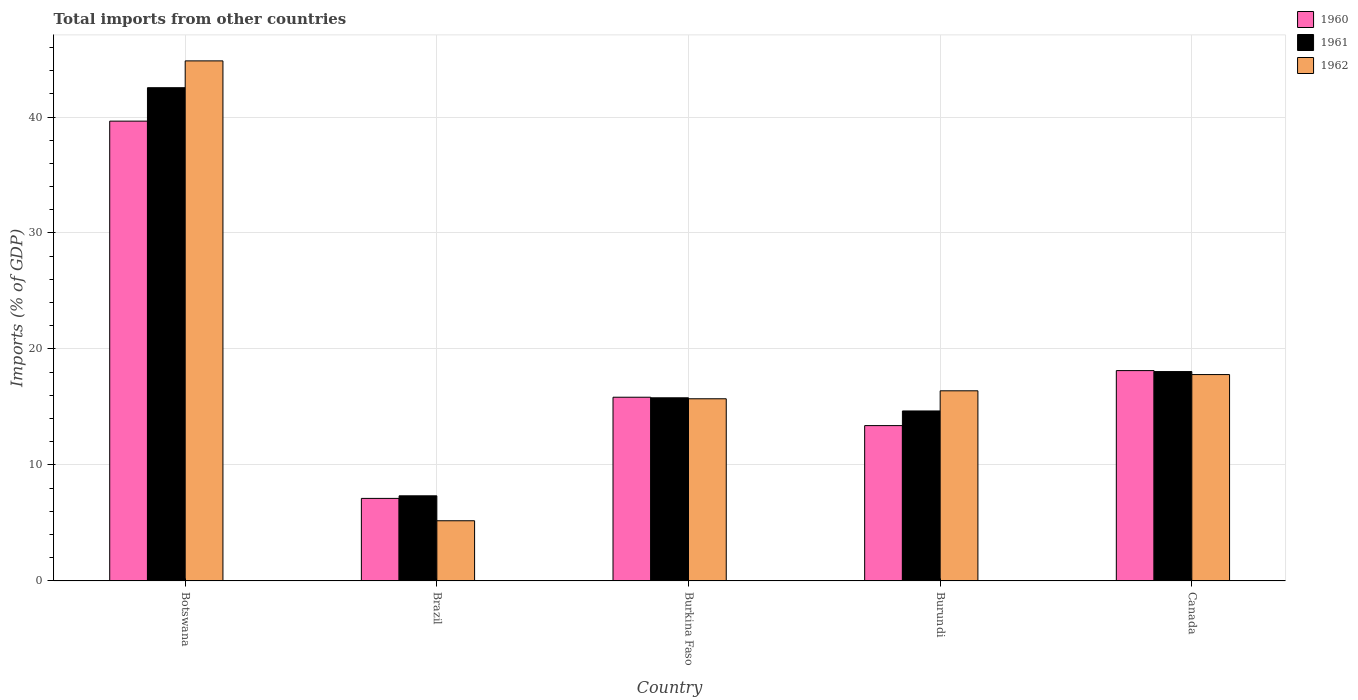Are the number of bars on each tick of the X-axis equal?
Your answer should be compact. Yes. How many bars are there on the 4th tick from the left?
Ensure brevity in your answer.  3. How many bars are there on the 2nd tick from the right?
Your answer should be compact. 3. What is the label of the 1st group of bars from the left?
Make the answer very short. Botswana. What is the total imports in 1960 in Burkina Faso?
Keep it short and to the point. 15.84. Across all countries, what is the maximum total imports in 1962?
Offer a very short reply. 44.84. Across all countries, what is the minimum total imports in 1961?
Your response must be concise. 7.34. In which country was the total imports in 1960 maximum?
Make the answer very short. Botswana. What is the total total imports in 1960 in the graph?
Keep it short and to the point. 94.13. What is the difference between the total imports in 1960 in Brazil and that in Burundi?
Make the answer very short. -6.28. What is the difference between the total imports in 1961 in Brazil and the total imports in 1960 in Botswana?
Provide a short and direct response. -32.3. What is the average total imports in 1962 per country?
Ensure brevity in your answer.  19.98. What is the difference between the total imports of/in 1961 and total imports of/in 1962 in Burkina Faso?
Provide a succinct answer. 0.08. In how many countries, is the total imports in 1960 greater than 30 %?
Your answer should be very brief. 1. What is the ratio of the total imports in 1960 in Burkina Faso to that in Canada?
Give a very brief answer. 0.87. What is the difference between the highest and the second highest total imports in 1960?
Give a very brief answer. 2.3. What is the difference between the highest and the lowest total imports in 1960?
Give a very brief answer. 32.53. What does the 3rd bar from the right in Brazil represents?
Your response must be concise. 1960. Are the values on the major ticks of Y-axis written in scientific E-notation?
Your response must be concise. No. Does the graph contain any zero values?
Your answer should be very brief. No. Does the graph contain grids?
Keep it short and to the point. Yes. Where does the legend appear in the graph?
Provide a short and direct response. Top right. How many legend labels are there?
Offer a very short reply. 3. How are the legend labels stacked?
Give a very brief answer. Vertical. What is the title of the graph?
Your answer should be compact. Total imports from other countries. Does "1983" appear as one of the legend labels in the graph?
Make the answer very short. No. What is the label or title of the X-axis?
Your response must be concise. Country. What is the label or title of the Y-axis?
Your response must be concise. Imports (% of GDP). What is the Imports (% of GDP) in 1960 in Botswana?
Provide a short and direct response. 39.64. What is the Imports (% of GDP) of 1961 in Botswana?
Provide a succinct answer. 42.53. What is the Imports (% of GDP) in 1962 in Botswana?
Your answer should be compact. 44.84. What is the Imports (% of GDP) in 1960 in Brazil?
Your answer should be very brief. 7.12. What is the Imports (% of GDP) in 1961 in Brazil?
Keep it short and to the point. 7.34. What is the Imports (% of GDP) in 1962 in Brazil?
Offer a terse response. 5.19. What is the Imports (% of GDP) of 1960 in Burkina Faso?
Make the answer very short. 15.84. What is the Imports (% of GDP) of 1961 in Burkina Faso?
Make the answer very short. 15.79. What is the Imports (% of GDP) in 1962 in Burkina Faso?
Keep it short and to the point. 15.71. What is the Imports (% of GDP) of 1960 in Burundi?
Provide a short and direct response. 13.39. What is the Imports (% of GDP) in 1961 in Burundi?
Give a very brief answer. 14.66. What is the Imports (% of GDP) of 1962 in Burundi?
Make the answer very short. 16.39. What is the Imports (% of GDP) of 1960 in Canada?
Offer a very short reply. 18.14. What is the Imports (% of GDP) in 1961 in Canada?
Offer a terse response. 18.05. What is the Imports (% of GDP) of 1962 in Canada?
Your answer should be compact. 17.79. Across all countries, what is the maximum Imports (% of GDP) in 1960?
Make the answer very short. 39.64. Across all countries, what is the maximum Imports (% of GDP) in 1961?
Your answer should be very brief. 42.53. Across all countries, what is the maximum Imports (% of GDP) of 1962?
Provide a succinct answer. 44.84. Across all countries, what is the minimum Imports (% of GDP) in 1960?
Give a very brief answer. 7.12. Across all countries, what is the minimum Imports (% of GDP) of 1961?
Provide a succinct answer. 7.34. Across all countries, what is the minimum Imports (% of GDP) in 1962?
Ensure brevity in your answer.  5.19. What is the total Imports (% of GDP) of 1960 in the graph?
Make the answer very short. 94.13. What is the total Imports (% of GDP) in 1961 in the graph?
Ensure brevity in your answer.  98.36. What is the total Imports (% of GDP) of 1962 in the graph?
Your answer should be compact. 99.92. What is the difference between the Imports (% of GDP) of 1960 in Botswana and that in Brazil?
Your answer should be very brief. 32.53. What is the difference between the Imports (% of GDP) in 1961 in Botswana and that in Brazil?
Your answer should be very brief. 35.19. What is the difference between the Imports (% of GDP) of 1962 in Botswana and that in Brazil?
Provide a succinct answer. 39.65. What is the difference between the Imports (% of GDP) in 1960 in Botswana and that in Burkina Faso?
Offer a very short reply. 23.8. What is the difference between the Imports (% of GDP) of 1961 in Botswana and that in Burkina Faso?
Offer a terse response. 26.74. What is the difference between the Imports (% of GDP) of 1962 in Botswana and that in Burkina Faso?
Your answer should be compact. 29.13. What is the difference between the Imports (% of GDP) of 1960 in Botswana and that in Burundi?
Offer a very short reply. 26.25. What is the difference between the Imports (% of GDP) of 1961 in Botswana and that in Burundi?
Provide a short and direct response. 27.87. What is the difference between the Imports (% of GDP) of 1962 in Botswana and that in Burundi?
Make the answer very short. 28.45. What is the difference between the Imports (% of GDP) of 1960 in Botswana and that in Canada?
Offer a very short reply. 21.51. What is the difference between the Imports (% of GDP) of 1961 in Botswana and that in Canada?
Ensure brevity in your answer.  24.47. What is the difference between the Imports (% of GDP) of 1962 in Botswana and that in Canada?
Offer a very short reply. 27.05. What is the difference between the Imports (% of GDP) in 1960 in Brazil and that in Burkina Faso?
Your answer should be very brief. -8.72. What is the difference between the Imports (% of GDP) of 1961 in Brazil and that in Burkina Faso?
Make the answer very short. -8.45. What is the difference between the Imports (% of GDP) of 1962 in Brazil and that in Burkina Faso?
Offer a very short reply. -10.52. What is the difference between the Imports (% of GDP) of 1960 in Brazil and that in Burundi?
Offer a very short reply. -6.28. What is the difference between the Imports (% of GDP) in 1961 in Brazil and that in Burundi?
Give a very brief answer. -7.32. What is the difference between the Imports (% of GDP) of 1962 in Brazil and that in Burundi?
Give a very brief answer. -11.2. What is the difference between the Imports (% of GDP) of 1960 in Brazil and that in Canada?
Offer a terse response. -11.02. What is the difference between the Imports (% of GDP) of 1961 in Brazil and that in Canada?
Your answer should be compact. -10.71. What is the difference between the Imports (% of GDP) of 1962 in Brazil and that in Canada?
Keep it short and to the point. -12.6. What is the difference between the Imports (% of GDP) of 1960 in Burkina Faso and that in Burundi?
Ensure brevity in your answer.  2.45. What is the difference between the Imports (% of GDP) of 1961 in Burkina Faso and that in Burundi?
Keep it short and to the point. 1.13. What is the difference between the Imports (% of GDP) in 1962 in Burkina Faso and that in Burundi?
Keep it short and to the point. -0.69. What is the difference between the Imports (% of GDP) in 1960 in Burkina Faso and that in Canada?
Provide a succinct answer. -2.3. What is the difference between the Imports (% of GDP) in 1961 in Burkina Faso and that in Canada?
Offer a terse response. -2.26. What is the difference between the Imports (% of GDP) of 1962 in Burkina Faso and that in Canada?
Provide a succinct answer. -2.09. What is the difference between the Imports (% of GDP) of 1960 in Burundi and that in Canada?
Give a very brief answer. -4.74. What is the difference between the Imports (% of GDP) of 1961 in Burundi and that in Canada?
Keep it short and to the point. -3.4. What is the difference between the Imports (% of GDP) in 1962 in Burundi and that in Canada?
Your answer should be very brief. -1.4. What is the difference between the Imports (% of GDP) of 1960 in Botswana and the Imports (% of GDP) of 1961 in Brazil?
Offer a terse response. 32.3. What is the difference between the Imports (% of GDP) of 1960 in Botswana and the Imports (% of GDP) of 1962 in Brazil?
Your answer should be compact. 34.45. What is the difference between the Imports (% of GDP) of 1961 in Botswana and the Imports (% of GDP) of 1962 in Brazil?
Offer a very short reply. 37.34. What is the difference between the Imports (% of GDP) of 1960 in Botswana and the Imports (% of GDP) of 1961 in Burkina Faso?
Your response must be concise. 23.85. What is the difference between the Imports (% of GDP) in 1960 in Botswana and the Imports (% of GDP) in 1962 in Burkina Faso?
Give a very brief answer. 23.94. What is the difference between the Imports (% of GDP) in 1961 in Botswana and the Imports (% of GDP) in 1962 in Burkina Faso?
Keep it short and to the point. 26.82. What is the difference between the Imports (% of GDP) of 1960 in Botswana and the Imports (% of GDP) of 1961 in Burundi?
Offer a very short reply. 24.99. What is the difference between the Imports (% of GDP) of 1960 in Botswana and the Imports (% of GDP) of 1962 in Burundi?
Your response must be concise. 23.25. What is the difference between the Imports (% of GDP) of 1961 in Botswana and the Imports (% of GDP) of 1962 in Burundi?
Offer a terse response. 26.13. What is the difference between the Imports (% of GDP) in 1960 in Botswana and the Imports (% of GDP) in 1961 in Canada?
Offer a terse response. 21.59. What is the difference between the Imports (% of GDP) of 1960 in Botswana and the Imports (% of GDP) of 1962 in Canada?
Offer a very short reply. 21.85. What is the difference between the Imports (% of GDP) in 1961 in Botswana and the Imports (% of GDP) in 1962 in Canada?
Make the answer very short. 24.73. What is the difference between the Imports (% of GDP) in 1960 in Brazil and the Imports (% of GDP) in 1961 in Burkina Faso?
Offer a terse response. -8.67. What is the difference between the Imports (% of GDP) of 1960 in Brazil and the Imports (% of GDP) of 1962 in Burkina Faso?
Make the answer very short. -8.59. What is the difference between the Imports (% of GDP) of 1961 in Brazil and the Imports (% of GDP) of 1962 in Burkina Faso?
Provide a short and direct response. -8.37. What is the difference between the Imports (% of GDP) in 1960 in Brazil and the Imports (% of GDP) in 1961 in Burundi?
Keep it short and to the point. -7.54. What is the difference between the Imports (% of GDP) of 1960 in Brazil and the Imports (% of GDP) of 1962 in Burundi?
Your answer should be compact. -9.28. What is the difference between the Imports (% of GDP) of 1961 in Brazil and the Imports (% of GDP) of 1962 in Burundi?
Ensure brevity in your answer.  -9.05. What is the difference between the Imports (% of GDP) in 1960 in Brazil and the Imports (% of GDP) in 1961 in Canada?
Provide a short and direct response. -10.93. What is the difference between the Imports (% of GDP) of 1960 in Brazil and the Imports (% of GDP) of 1962 in Canada?
Your answer should be compact. -10.68. What is the difference between the Imports (% of GDP) of 1961 in Brazil and the Imports (% of GDP) of 1962 in Canada?
Your response must be concise. -10.45. What is the difference between the Imports (% of GDP) of 1960 in Burkina Faso and the Imports (% of GDP) of 1961 in Burundi?
Keep it short and to the point. 1.18. What is the difference between the Imports (% of GDP) of 1960 in Burkina Faso and the Imports (% of GDP) of 1962 in Burundi?
Provide a succinct answer. -0.55. What is the difference between the Imports (% of GDP) of 1961 in Burkina Faso and the Imports (% of GDP) of 1962 in Burundi?
Your answer should be compact. -0.6. What is the difference between the Imports (% of GDP) in 1960 in Burkina Faso and the Imports (% of GDP) in 1961 in Canada?
Your response must be concise. -2.21. What is the difference between the Imports (% of GDP) in 1960 in Burkina Faso and the Imports (% of GDP) in 1962 in Canada?
Provide a succinct answer. -1.95. What is the difference between the Imports (% of GDP) in 1961 in Burkina Faso and the Imports (% of GDP) in 1962 in Canada?
Your answer should be compact. -2. What is the difference between the Imports (% of GDP) of 1960 in Burundi and the Imports (% of GDP) of 1961 in Canada?
Give a very brief answer. -4.66. What is the difference between the Imports (% of GDP) in 1960 in Burundi and the Imports (% of GDP) in 1962 in Canada?
Keep it short and to the point. -4.4. What is the difference between the Imports (% of GDP) in 1961 in Burundi and the Imports (% of GDP) in 1962 in Canada?
Make the answer very short. -3.14. What is the average Imports (% of GDP) of 1960 per country?
Offer a terse response. 18.83. What is the average Imports (% of GDP) in 1961 per country?
Provide a short and direct response. 19.67. What is the average Imports (% of GDP) in 1962 per country?
Keep it short and to the point. 19.98. What is the difference between the Imports (% of GDP) in 1960 and Imports (% of GDP) in 1961 in Botswana?
Make the answer very short. -2.88. What is the difference between the Imports (% of GDP) in 1960 and Imports (% of GDP) in 1962 in Botswana?
Your answer should be very brief. -5.2. What is the difference between the Imports (% of GDP) of 1961 and Imports (% of GDP) of 1962 in Botswana?
Keep it short and to the point. -2.31. What is the difference between the Imports (% of GDP) in 1960 and Imports (% of GDP) in 1961 in Brazil?
Offer a terse response. -0.22. What is the difference between the Imports (% of GDP) of 1960 and Imports (% of GDP) of 1962 in Brazil?
Provide a succinct answer. 1.93. What is the difference between the Imports (% of GDP) of 1961 and Imports (% of GDP) of 1962 in Brazil?
Keep it short and to the point. 2.15. What is the difference between the Imports (% of GDP) in 1960 and Imports (% of GDP) in 1961 in Burkina Faso?
Your answer should be compact. 0.05. What is the difference between the Imports (% of GDP) in 1960 and Imports (% of GDP) in 1962 in Burkina Faso?
Your response must be concise. 0.13. What is the difference between the Imports (% of GDP) of 1961 and Imports (% of GDP) of 1962 in Burkina Faso?
Your response must be concise. 0.08. What is the difference between the Imports (% of GDP) of 1960 and Imports (% of GDP) of 1961 in Burundi?
Your answer should be very brief. -1.26. What is the difference between the Imports (% of GDP) in 1960 and Imports (% of GDP) in 1962 in Burundi?
Give a very brief answer. -3. What is the difference between the Imports (% of GDP) of 1961 and Imports (% of GDP) of 1962 in Burundi?
Keep it short and to the point. -1.74. What is the difference between the Imports (% of GDP) in 1960 and Imports (% of GDP) in 1961 in Canada?
Offer a very short reply. 0.08. What is the difference between the Imports (% of GDP) in 1960 and Imports (% of GDP) in 1962 in Canada?
Your answer should be compact. 0.34. What is the difference between the Imports (% of GDP) in 1961 and Imports (% of GDP) in 1962 in Canada?
Provide a succinct answer. 0.26. What is the ratio of the Imports (% of GDP) in 1960 in Botswana to that in Brazil?
Offer a terse response. 5.57. What is the ratio of the Imports (% of GDP) of 1961 in Botswana to that in Brazil?
Make the answer very short. 5.79. What is the ratio of the Imports (% of GDP) in 1962 in Botswana to that in Brazil?
Provide a succinct answer. 8.64. What is the ratio of the Imports (% of GDP) in 1960 in Botswana to that in Burkina Faso?
Provide a short and direct response. 2.5. What is the ratio of the Imports (% of GDP) of 1961 in Botswana to that in Burkina Faso?
Ensure brevity in your answer.  2.69. What is the ratio of the Imports (% of GDP) of 1962 in Botswana to that in Burkina Faso?
Provide a succinct answer. 2.85. What is the ratio of the Imports (% of GDP) of 1960 in Botswana to that in Burundi?
Your answer should be compact. 2.96. What is the ratio of the Imports (% of GDP) in 1961 in Botswana to that in Burundi?
Give a very brief answer. 2.9. What is the ratio of the Imports (% of GDP) of 1962 in Botswana to that in Burundi?
Offer a terse response. 2.74. What is the ratio of the Imports (% of GDP) in 1960 in Botswana to that in Canada?
Keep it short and to the point. 2.19. What is the ratio of the Imports (% of GDP) of 1961 in Botswana to that in Canada?
Make the answer very short. 2.36. What is the ratio of the Imports (% of GDP) of 1962 in Botswana to that in Canada?
Offer a very short reply. 2.52. What is the ratio of the Imports (% of GDP) of 1960 in Brazil to that in Burkina Faso?
Your response must be concise. 0.45. What is the ratio of the Imports (% of GDP) in 1961 in Brazil to that in Burkina Faso?
Offer a terse response. 0.46. What is the ratio of the Imports (% of GDP) in 1962 in Brazil to that in Burkina Faso?
Ensure brevity in your answer.  0.33. What is the ratio of the Imports (% of GDP) of 1960 in Brazil to that in Burundi?
Make the answer very short. 0.53. What is the ratio of the Imports (% of GDP) in 1961 in Brazil to that in Burundi?
Your answer should be compact. 0.5. What is the ratio of the Imports (% of GDP) of 1962 in Brazil to that in Burundi?
Your answer should be compact. 0.32. What is the ratio of the Imports (% of GDP) in 1960 in Brazil to that in Canada?
Give a very brief answer. 0.39. What is the ratio of the Imports (% of GDP) of 1961 in Brazil to that in Canada?
Provide a succinct answer. 0.41. What is the ratio of the Imports (% of GDP) in 1962 in Brazil to that in Canada?
Make the answer very short. 0.29. What is the ratio of the Imports (% of GDP) of 1960 in Burkina Faso to that in Burundi?
Make the answer very short. 1.18. What is the ratio of the Imports (% of GDP) of 1961 in Burkina Faso to that in Burundi?
Provide a short and direct response. 1.08. What is the ratio of the Imports (% of GDP) of 1962 in Burkina Faso to that in Burundi?
Your answer should be very brief. 0.96. What is the ratio of the Imports (% of GDP) of 1960 in Burkina Faso to that in Canada?
Offer a very short reply. 0.87. What is the ratio of the Imports (% of GDP) in 1961 in Burkina Faso to that in Canada?
Your answer should be very brief. 0.87. What is the ratio of the Imports (% of GDP) of 1962 in Burkina Faso to that in Canada?
Your response must be concise. 0.88. What is the ratio of the Imports (% of GDP) of 1960 in Burundi to that in Canada?
Your answer should be very brief. 0.74. What is the ratio of the Imports (% of GDP) in 1961 in Burundi to that in Canada?
Provide a short and direct response. 0.81. What is the ratio of the Imports (% of GDP) of 1962 in Burundi to that in Canada?
Offer a very short reply. 0.92. What is the difference between the highest and the second highest Imports (% of GDP) in 1960?
Your answer should be very brief. 21.51. What is the difference between the highest and the second highest Imports (% of GDP) in 1961?
Your answer should be compact. 24.47. What is the difference between the highest and the second highest Imports (% of GDP) in 1962?
Make the answer very short. 27.05. What is the difference between the highest and the lowest Imports (% of GDP) in 1960?
Give a very brief answer. 32.53. What is the difference between the highest and the lowest Imports (% of GDP) of 1961?
Keep it short and to the point. 35.19. What is the difference between the highest and the lowest Imports (% of GDP) of 1962?
Ensure brevity in your answer.  39.65. 